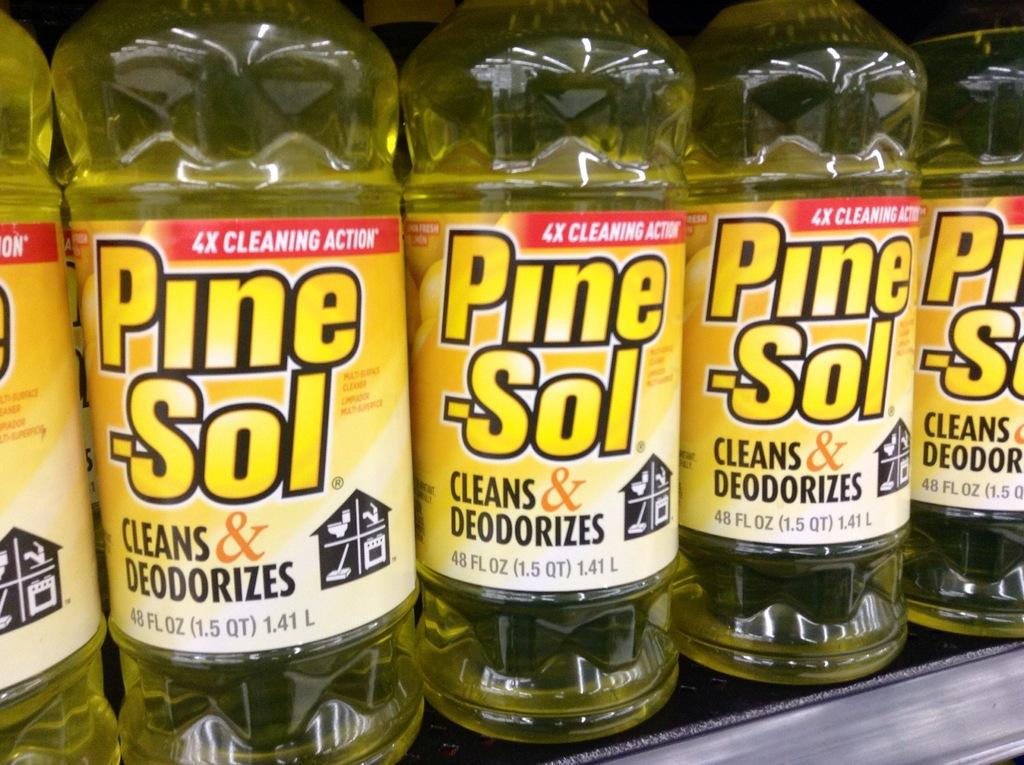<image>
Create a compact narrative representing the image presented. Many bottles of Pine-Sol in a store for sale. 